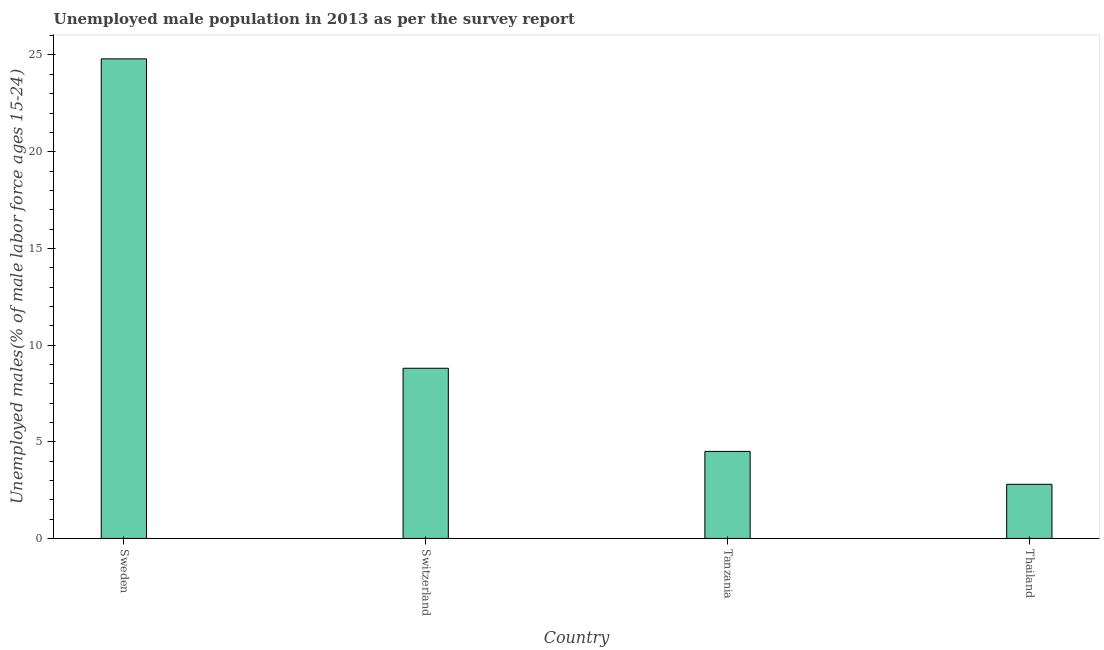Does the graph contain grids?
Offer a very short reply. No. What is the title of the graph?
Give a very brief answer. Unemployed male population in 2013 as per the survey report. What is the label or title of the X-axis?
Keep it short and to the point. Country. What is the label or title of the Y-axis?
Ensure brevity in your answer.  Unemployed males(% of male labor force ages 15-24). What is the unemployed male youth in Tanzania?
Provide a short and direct response. 4.5. Across all countries, what is the maximum unemployed male youth?
Give a very brief answer. 24.8. Across all countries, what is the minimum unemployed male youth?
Ensure brevity in your answer.  2.8. In which country was the unemployed male youth maximum?
Provide a short and direct response. Sweden. In which country was the unemployed male youth minimum?
Your answer should be very brief. Thailand. What is the sum of the unemployed male youth?
Offer a terse response. 40.9. What is the difference between the unemployed male youth in Sweden and Switzerland?
Ensure brevity in your answer.  16. What is the average unemployed male youth per country?
Offer a very short reply. 10.22. What is the median unemployed male youth?
Provide a short and direct response. 6.65. What is the ratio of the unemployed male youth in Sweden to that in Tanzania?
Give a very brief answer. 5.51. Is the unemployed male youth in Sweden less than that in Switzerland?
Your answer should be very brief. No. Is the difference between the unemployed male youth in Sweden and Thailand greater than the difference between any two countries?
Offer a very short reply. Yes. Is the sum of the unemployed male youth in Sweden and Thailand greater than the maximum unemployed male youth across all countries?
Provide a succinct answer. Yes. How many bars are there?
Keep it short and to the point. 4. What is the difference between two consecutive major ticks on the Y-axis?
Your response must be concise. 5. Are the values on the major ticks of Y-axis written in scientific E-notation?
Make the answer very short. No. What is the Unemployed males(% of male labor force ages 15-24) of Sweden?
Give a very brief answer. 24.8. What is the Unemployed males(% of male labor force ages 15-24) of Switzerland?
Offer a terse response. 8.8. What is the Unemployed males(% of male labor force ages 15-24) of Thailand?
Give a very brief answer. 2.8. What is the difference between the Unemployed males(% of male labor force ages 15-24) in Sweden and Tanzania?
Make the answer very short. 20.3. What is the difference between the Unemployed males(% of male labor force ages 15-24) in Switzerland and Tanzania?
Keep it short and to the point. 4.3. What is the ratio of the Unemployed males(% of male labor force ages 15-24) in Sweden to that in Switzerland?
Keep it short and to the point. 2.82. What is the ratio of the Unemployed males(% of male labor force ages 15-24) in Sweden to that in Tanzania?
Your response must be concise. 5.51. What is the ratio of the Unemployed males(% of male labor force ages 15-24) in Sweden to that in Thailand?
Keep it short and to the point. 8.86. What is the ratio of the Unemployed males(% of male labor force ages 15-24) in Switzerland to that in Tanzania?
Keep it short and to the point. 1.96. What is the ratio of the Unemployed males(% of male labor force ages 15-24) in Switzerland to that in Thailand?
Give a very brief answer. 3.14. What is the ratio of the Unemployed males(% of male labor force ages 15-24) in Tanzania to that in Thailand?
Your answer should be very brief. 1.61. 